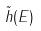Convert formula to latex. <formula><loc_0><loc_0><loc_500><loc_500>\tilde { h } ( E )</formula> 